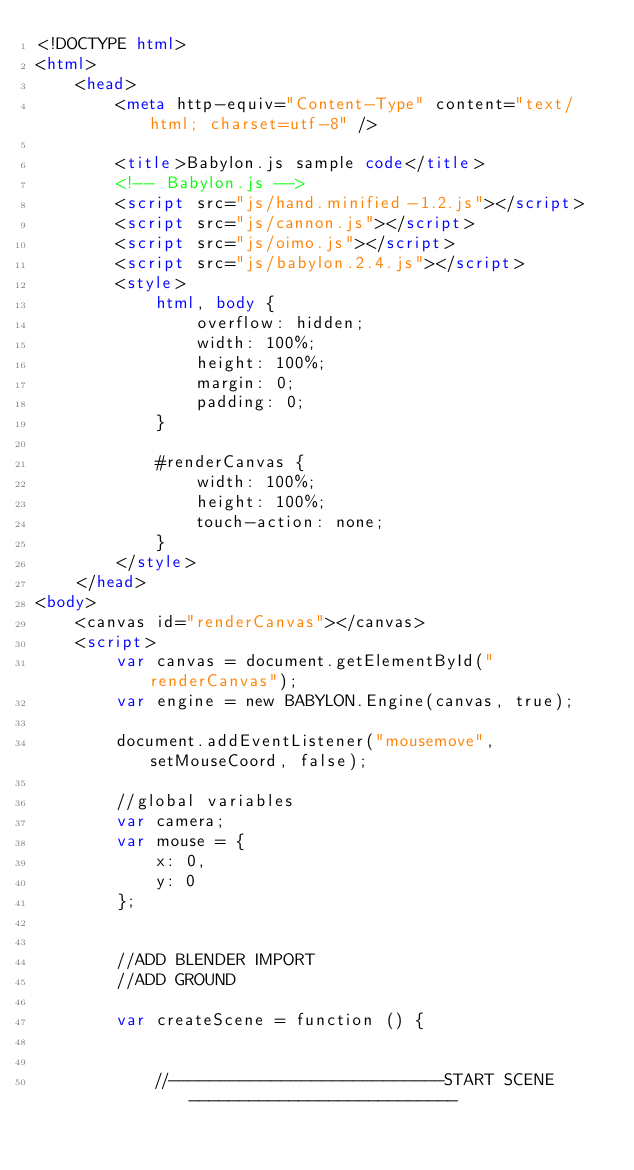<code> <loc_0><loc_0><loc_500><loc_500><_HTML_><!DOCTYPE html>
<html>
    <head>
        <meta http-equiv="Content-Type" content="text/html; charset=utf-8" />

        <title>Babylon.js sample code</title>
        <!-- Babylon.js -->
        <script src="js/hand.minified-1.2.js"></script>
        <script src="js/cannon.js"></script>
        <script src="js/oimo.js"></script>
        <script src="js/babylon.2.4.js"></script>
        <style>
            html, body {
                overflow: hidden;
                width: 100%;
                height: 100%;
                margin: 0;
                padding: 0;
            }

            #renderCanvas {
                width: 100%;
                height: 100%;
                touch-action: none;
            }
        </style>
    </head>
<body>
    <canvas id="renderCanvas"></canvas>
    <script>
        var canvas = document.getElementById("renderCanvas");
        var engine = new BABYLON.Engine(canvas, true);

        document.addEventListener("mousemove", setMouseCoord, false);
        
        //global variables
        var camera;
        var mouse = {
            x: 0,
            y: 0
        };
        
        
        //ADD BLENDER IMPORT
        //ADD GROUND
        
        var createScene = function () {
        	
        	
        	//---------------------------START SCENE---------------------------
        	</code> 